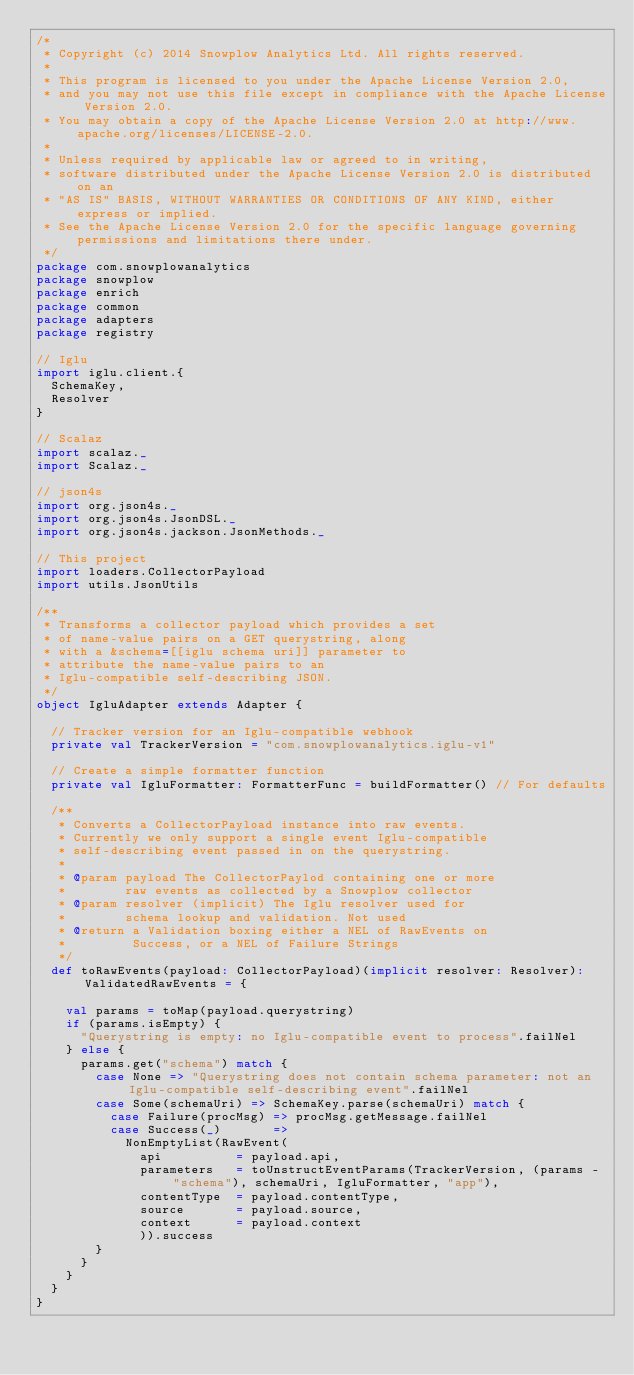<code> <loc_0><loc_0><loc_500><loc_500><_Scala_>/*
 * Copyright (c) 2014 Snowplow Analytics Ltd. All rights reserved.
 *
 * This program is licensed to you under the Apache License Version 2.0,
 * and you may not use this file except in compliance with the Apache License Version 2.0.
 * You may obtain a copy of the Apache License Version 2.0 at http://www.apache.org/licenses/LICENSE-2.0.
 *
 * Unless required by applicable law or agreed to in writing,
 * software distributed under the Apache License Version 2.0 is distributed on an
 * "AS IS" BASIS, WITHOUT WARRANTIES OR CONDITIONS OF ANY KIND, either express or implied.
 * See the Apache License Version 2.0 for the specific language governing permissions and limitations there under.
 */
package com.snowplowanalytics
package snowplow
package enrich
package common
package adapters
package registry

// Iglu
import iglu.client.{
  SchemaKey,
  Resolver
}

// Scalaz
import scalaz._
import Scalaz._

// json4s
import org.json4s._
import org.json4s.JsonDSL._
import org.json4s.jackson.JsonMethods._

// This project
import loaders.CollectorPayload
import utils.JsonUtils

/**
 * Transforms a collector payload which provides a set
 * of name-value pairs on a GET querystring, along
 * with a &schema=[[iglu schema uri]] parameter to
 * attribute the name-value pairs to an
 * Iglu-compatible self-describing JSON.
 */
object IgluAdapter extends Adapter {

  // Tracker version for an Iglu-compatible webhook
  private val TrackerVersion = "com.snowplowanalytics.iglu-v1"

  // Create a simple formatter function
  private val IgluFormatter: FormatterFunc = buildFormatter() // For defaults

  /**
   * Converts a CollectorPayload instance into raw events.
   * Currently we only support a single event Iglu-compatible
   * self-describing event passed in on the querystring.
   *
   * @param payload The CollectorPaylod containing one or more
   *        raw events as collected by a Snowplow collector
   * @param resolver (implicit) The Iglu resolver used for
   *        schema lookup and validation. Not used
   * @return a Validation boxing either a NEL of RawEvents on
   *         Success, or a NEL of Failure Strings
   */
  def toRawEvents(payload: CollectorPayload)(implicit resolver: Resolver): ValidatedRawEvents = {

    val params = toMap(payload.querystring)
    if (params.isEmpty) {
      "Querystring is empty: no Iglu-compatible event to process".failNel
    } else {
      params.get("schema") match {
        case None => "Querystring does not contain schema parameter: not an Iglu-compatible self-describing event".failNel
        case Some(schemaUri) => SchemaKey.parse(schemaUri) match {
          case Failure(procMsg) => procMsg.getMessage.failNel
          case Success(_)       =>
            NonEmptyList(RawEvent(
              api          = payload.api,
              parameters   = toUnstructEventParams(TrackerVersion, (params - "schema"), schemaUri, IgluFormatter, "app"),
              contentType  = payload.contentType,
              source       = payload.source,
              context      = payload.context
              )).success
        }
      }
    }
  }
}
</code> 